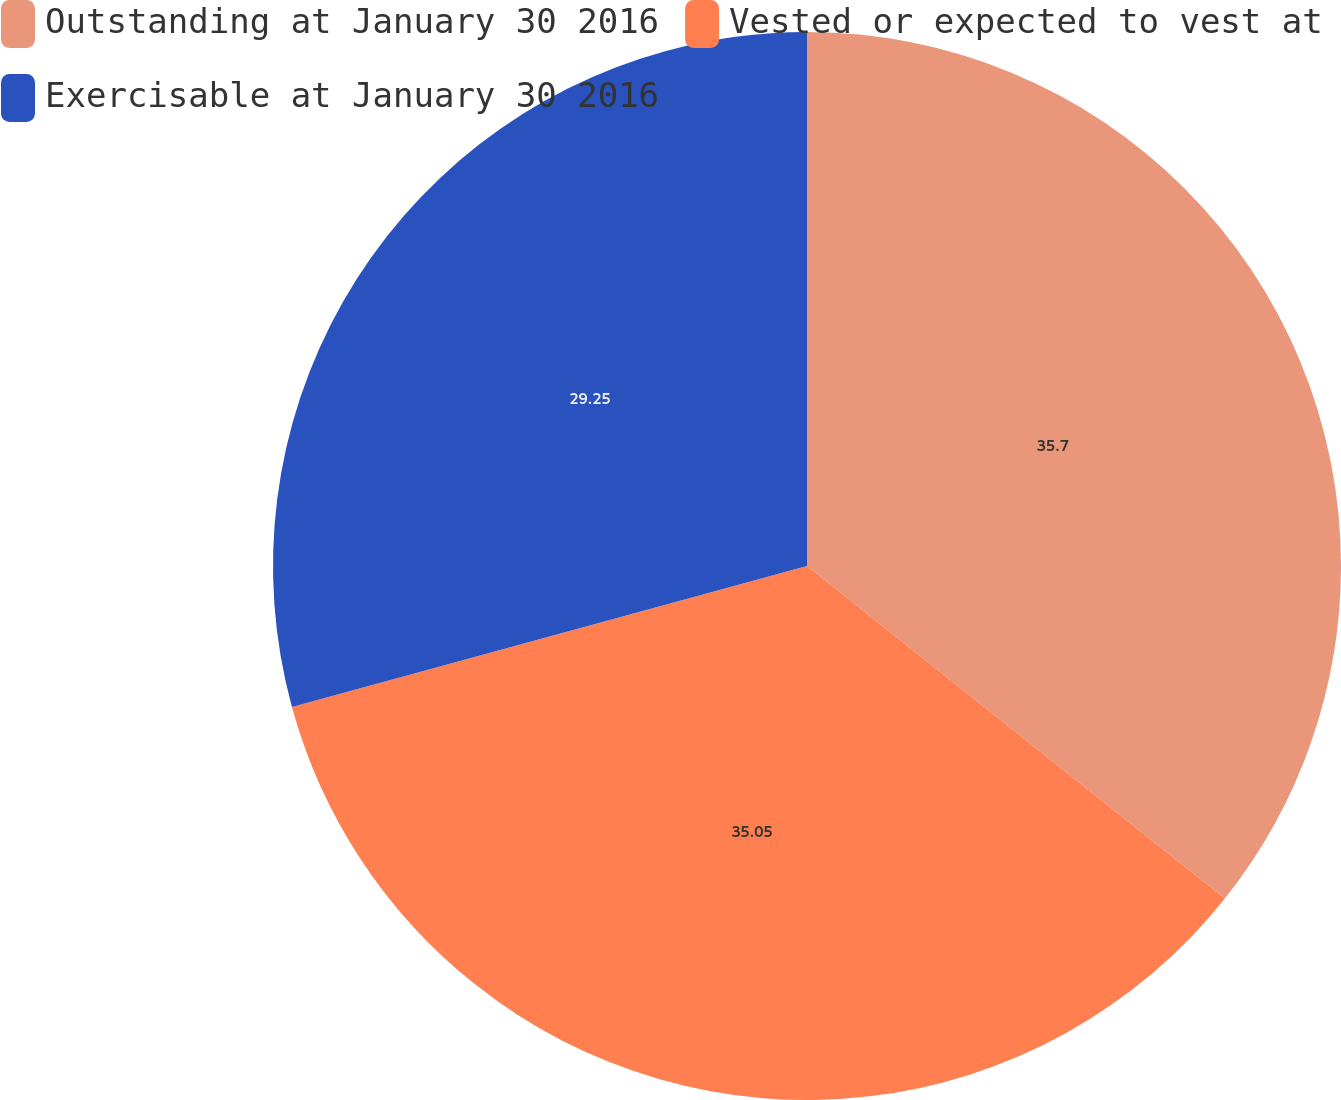Convert chart. <chart><loc_0><loc_0><loc_500><loc_500><pie_chart><fcel>Outstanding at January 30 2016<fcel>Vested or expected to vest at<fcel>Exercisable at January 30 2016<nl><fcel>35.7%<fcel>35.05%<fcel>29.25%<nl></chart> 